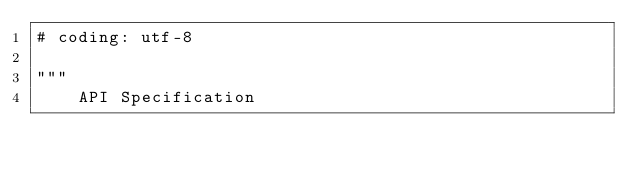<code> <loc_0><loc_0><loc_500><loc_500><_Python_># coding: utf-8

"""
    API Specification
</code> 